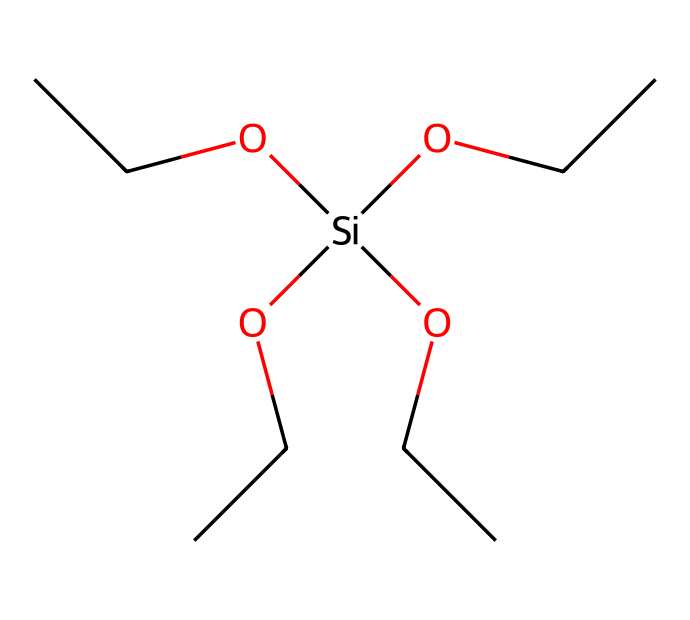What is the molecular formula of the silane coupling agent? To determine the molecular formula, count the number of each type of atom present in the SMILES representation. There are 9 carbon atoms, 20 hydrogen atoms, 1 silicon atom, and 3 oxygen atoms. The formula is C9H20O3Si.
Answer: C9H20O3Si How many silicon atoms are present in the chemical structure? The chemical structure has one silicon atom which can be identified by the presence of the '[Si]' part in the SMILES notation.
Answer: 1 What type of functional groups are present in this silane? The molecular structure includes ether groups indicated by the 'O' atoms connected to carbon chains (OCC), which are characteristic of silanes.
Answer: ether What is the significance of the branching in the carbon chains? The branching in the carbon chains increases the surface area of the molecule, enhancing its interaction with substrates in printing inks, improving adhesion.
Answer: increases adhesion How many total oxygen atoms are in this molecule? The molecule contains three oxygen atoms, which can be counted directly from the SMILES, where 'O' appears three times.
Answer: 3 What is the primary application of this silane coupling agent in printing inks? This silane coupling agent is primarily used to improve the bonding between the ink and substrate, thereby enhancing print durability and quality.
Answer: adhesion improvement 